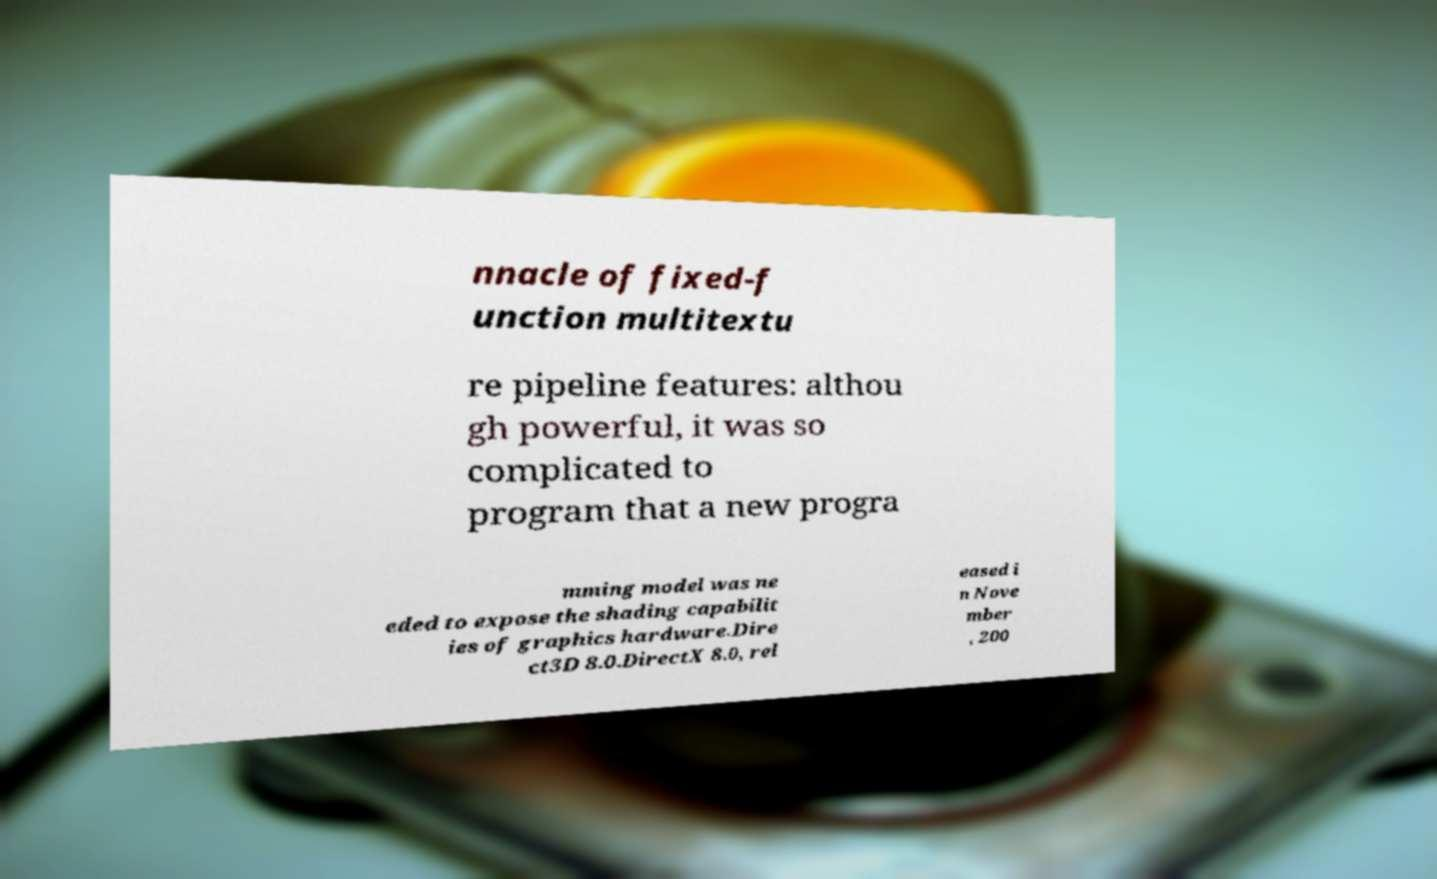Can you read and provide the text displayed in the image?This photo seems to have some interesting text. Can you extract and type it out for me? nnacle of fixed-f unction multitextu re pipeline features: althou gh powerful, it was so complicated to program that a new progra mming model was ne eded to expose the shading capabilit ies of graphics hardware.Dire ct3D 8.0.DirectX 8.0, rel eased i n Nove mber , 200 